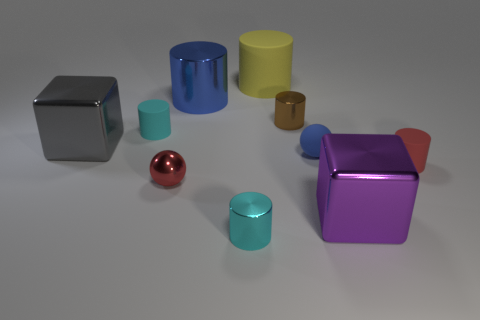Subtract all big blue cylinders. How many cylinders are left? 5 Subtract all blue cylinders. How many cylinders are left? 5 Subtract all cylinders. How many objects are left? 4 Subtract all big gray blocks. Subtract all tiny brown metal things. How many objects are left? 8 Add 6 rubber objects. How many rubber objects are left? 10 Add 6 large blue metallic objects. How many large blue metallic objects exist? 7 Subtract 0 purple spheres. How many objects are left? 10 Subtract 1 spheres. How many spheres are left? 1 Subtract all purple spheres. Subtract all red cylinders. How many spheres are left? 2 Subtract all gray cubes. How many red spheres are left? 1 